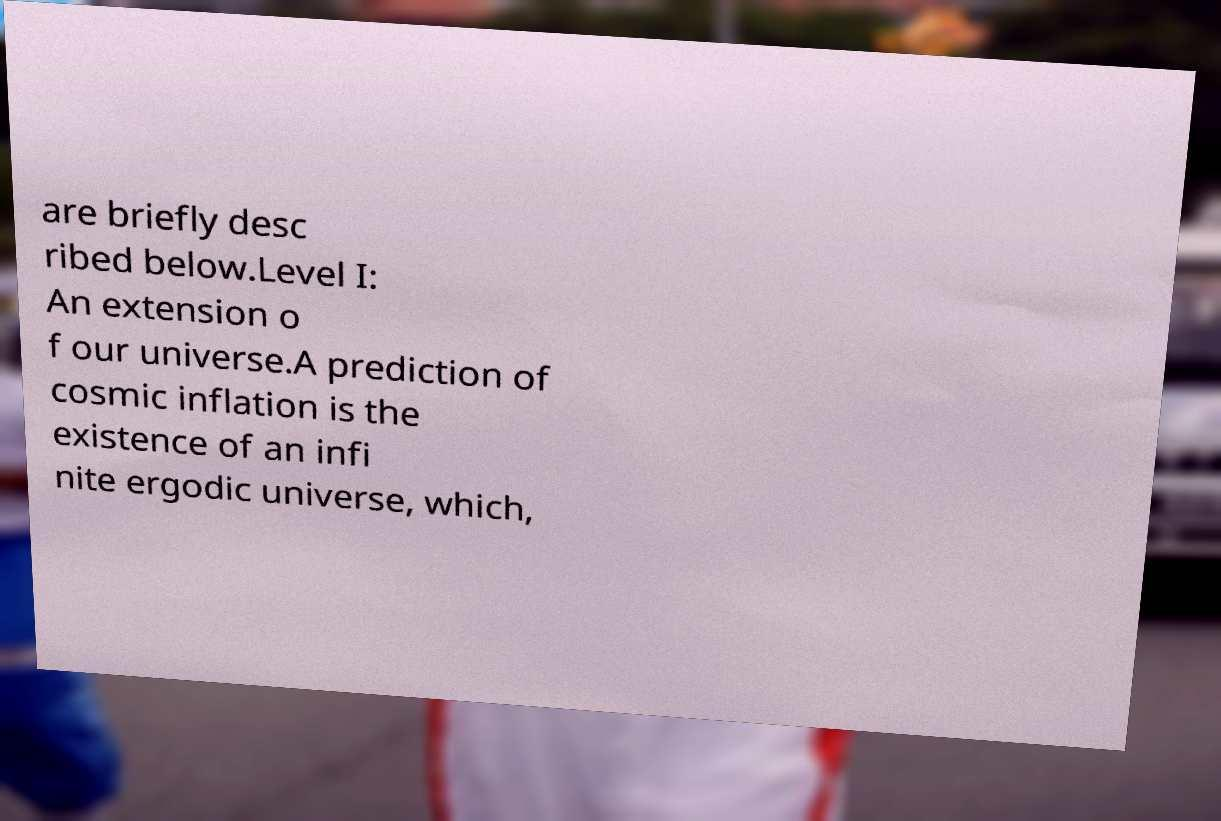Can you read and provide the text displayed in the image?This photo seems to have some interesting text. Can you extract and type it out for me? are briefly desc ribed below.Level I: An extension o f our universe.A prediction of cosmic inflation is the existence of an infi nite ergodic universe, which, 